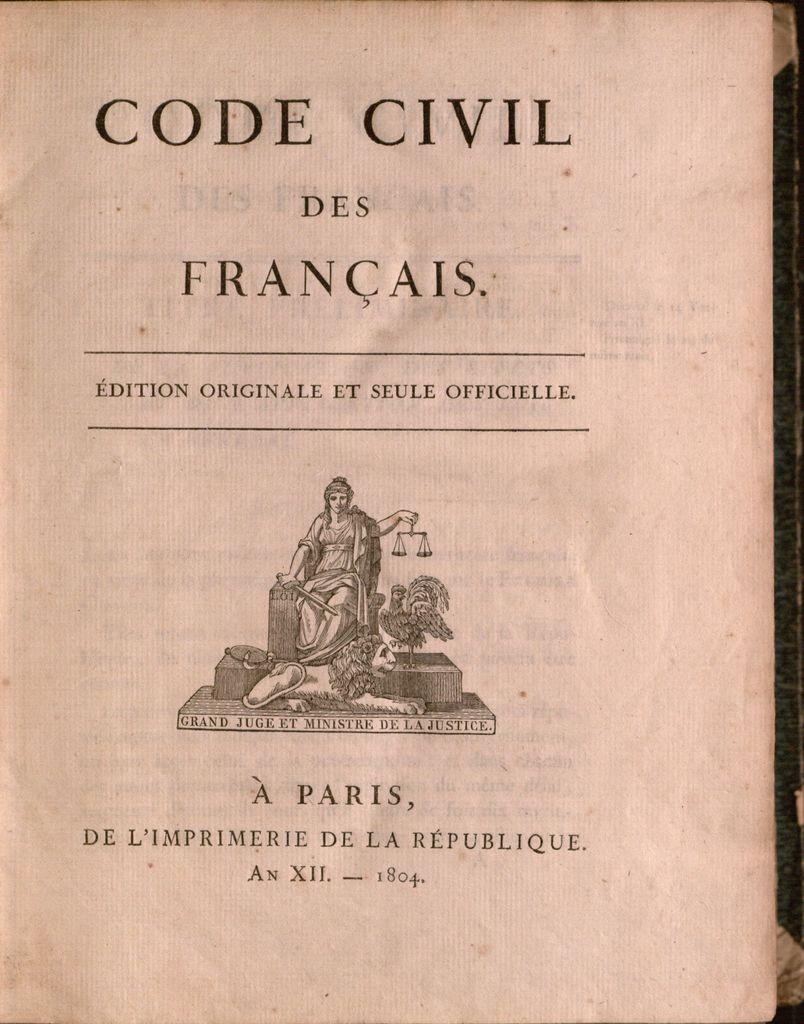What is the title of this book?
Your answer should be very brief. Code civil des francais. 